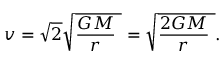<formula> <loc_0><loc_0><loc_500><loc_500>\ v = { \sqrt { 2 } } { \sqrt { { \frac { G M } { r } } \ } } = { \sqrt { { \frac { 2 G M } { r } } \ } } .</formula> 